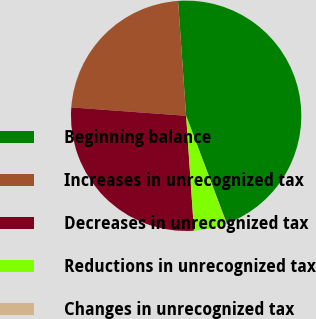Convert chart. <chart><loc_0><loc_0><loc_500><loc_500><pie_chart><fcel>Beginning balance<fcel>Increases in unrecognized tax<fcel>Decreases in unrecognized tax<fcel>Reductions in unrecognized tax<fcel>Changes in unrecognized tax<nl><fcel>45.38%<fcel>22.72%<fcel>27.25%<fcel>4.59%<fcel>0.06%<nl></chart> 